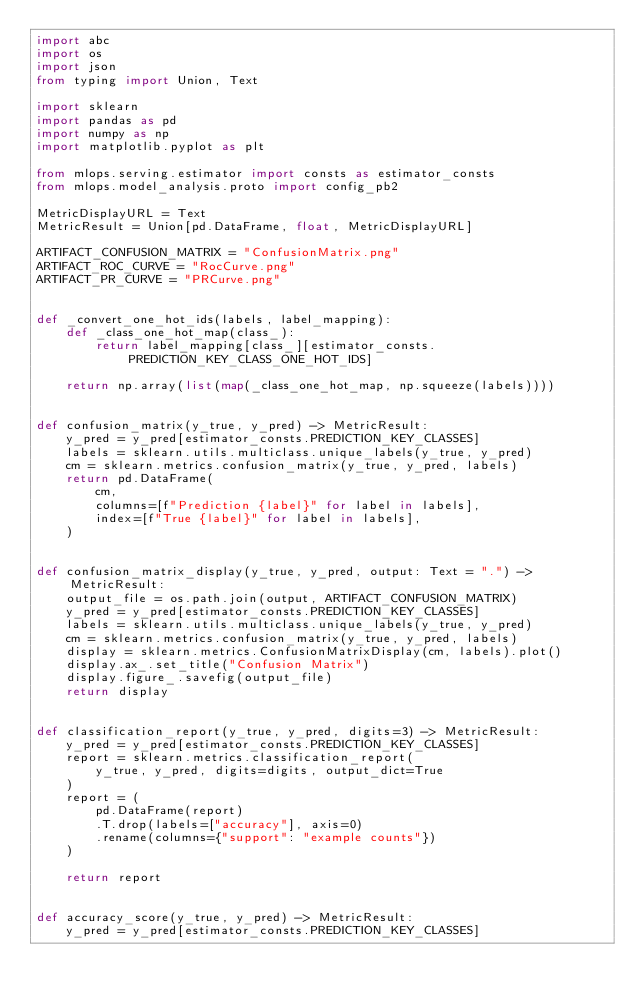Convert code to text. <code><loc_0><loc_0><loc_500><loc_500><_Python_>import abc
import os
import json
from typing import Union, Text

import sklearn
import pandas as pd
import numpy as np
import matplotlib.pyplot as plt

from mlops.serving.estimator import consts as estimator_consts
from mlops.model_analysis.proto import config_pb2

MetricDisplayURL = Text
MetricResult = Union[pd.DataFrame, float, MetricDisplayURL]

ARTIFACT_CONFUSION_MATRIX = "ConfusionMatrix.png"
ARTIFACT_ROC_CURVE = "RocCurve.png"
ARTIFACT_PR_CURVE = "PRCurve.png"


def _convert_one_hot_ids(labels, label_mapping):
    def _class_one_hot_map(class_):
        return label_mapping[class_][estimator_consts.PREDICTION_KEY_CLASS_ONE_HOT_IDS]

    return np.array(list(map(_class_one_hot_map, np.squeeze(labels))))


def confusion_matrix(y_true, y_pred) -> MetricResult:
    y_pred = y_pred[estimator_consts.PREDICTION_KEY_CLASSES]
    labels = sklearn.utils.multiclass.unique_labels(y_true, y_pred)
    cm = sklearn.metrics.confusion_matrix(y_true, y_pred, labels)
    return pd.DataFrame(
        cm,
        columns=[f"Prediction {label}" for label in labels],
        index=[f"True {label}" for label in labels],
    )


def confusion_matrix_display(y_true, y_pred, output: Text = ".") -> MetricResult:
    output_file = os.path.join(output, ARTIFACT_CONFUSION_MATRIX)
    y_pred = y_pred[estimator_consts.PREDICTION_KEY_CLASSES]
    labels = sklearn.utils.multiclass.unique_labels(y_true, y_pred)
    cm = sklearn.metrics.confusion_matrix(y_true, y_pred, labels)
    display = sklearn.metrics.ConfusionMatrixDisplay(cm, labels).plot()
    display.ax_.set_title("Confusion Matrix")
    display.figure_.savefig(output_file)
    return display


def classification_report(y_true, y_pred, digits=3) -> MetricResult:
    y_pred = y_pred[estimator_consts.PREDICTION_KEY_CLASSES]
    report = sklearn.metrics.classification_report(
        y_true, y_pred, digits=digits, output_dict=True
    )
    report = (
        pd.DataFrame(report)
        .T.drop(labels=["accuracy"], axis=0)
        .rename(columns={"support": "example counts"})
    )

    return report


def accuracy_score(y_true, y_pred) -> MetricResult:
    y_pred = y_pred[estimator_consts.PREDICTION_KEY_CLASSES]</code> 